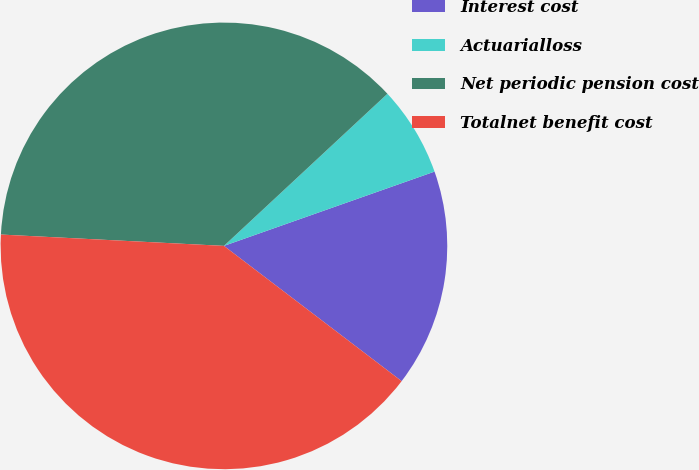<chart> <loc_0><loc_0><loc_500><loc_500><pie_chart><fcel>Interest cost<fcel>Actuarialloss<fcel>Net periodic pension cost<fcel>Totalnet benefit cost<nl><fcel>15.75%<fcel>6.53%<fcel>37.26%<fcel>40.45%<nl></chart> 